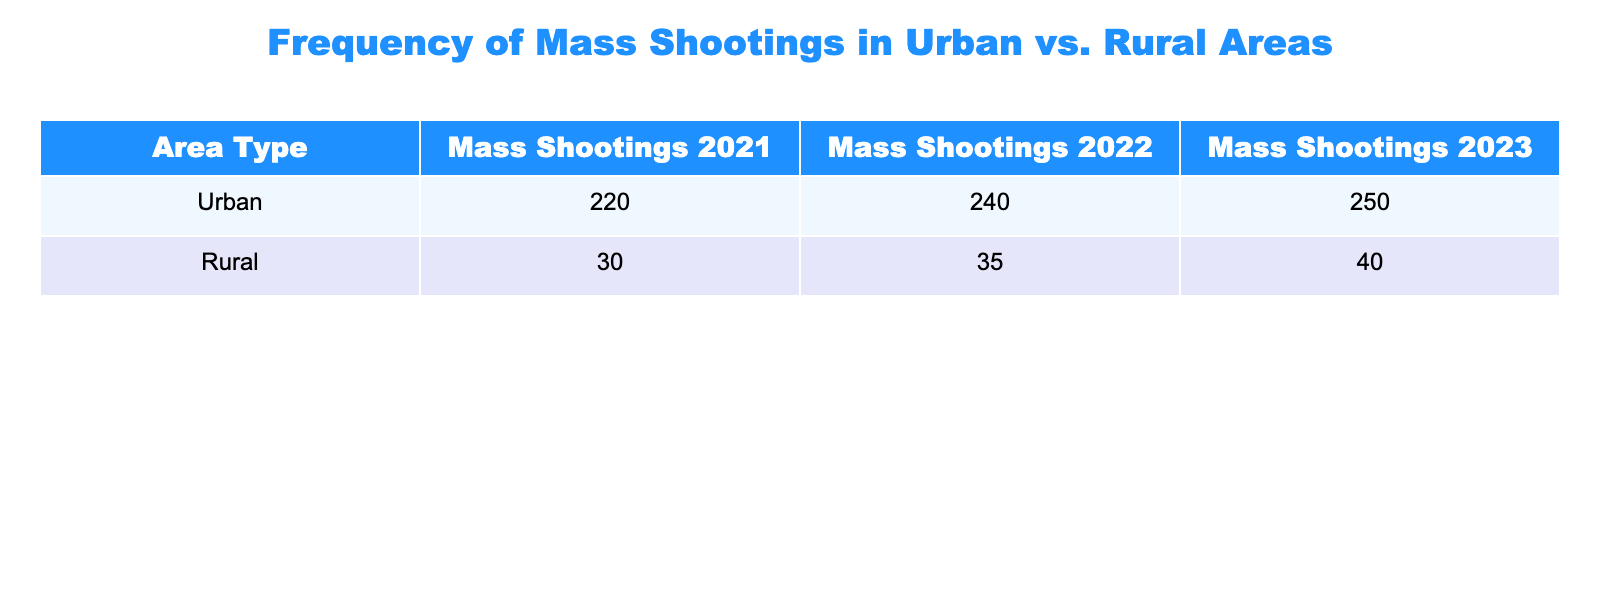What is the total number of mass shootings in rural areas from 2021 to 2023? To find the total number of mass shootings in rural areas, we need to add the mass shootings for each year. This gives us 30 (2021) + 35 (2022) + 40 (2023) = 105.
Answer: 105 How many more mass shootings occurred in urban areas than in rural areas in 2022? In 2022, there were 240 mass shootings in urban areas and 35 in rural areas. To find the difference, we subtract the rural shootings from urban shootings: 240 - 35 = 205.
Answer: 205 What is the average number of mass shootings per year in urban areas over the three years provided? To calculate the average, we add the mass shootings from each year: 220 (2021) + 240 (2022) + 250 (2023) = 710. Then, we divide by 3 (the number of years), so 710 / 3 = approximately 236.67.
Answer: 236.67 Is the number of mass shootings in urban areas greater than in rural areas for all three years? By checking each year's figures: 220 (urban) vs 30 (rural) in 2021, 240 (urban) vs 35 (rural) in 2022, and 250 (urban) vs 40 (rural) in 2023, it can be confirmed that urban shootings are greater each year.
Answer: Yes Which year saw the highest number of mass shootings in urban areas, and how many were there? Looking at the urban shooting data, 2021 had 220, 2022 had 240, and 2023 had 250. The year 2023 had the highest number, with 250 mass shootings.
Answer: 2023, 250 What was the percentage increase in mass shootings in rural areas from 2021 to 2023? To calculate the percentage increase, we first find the difference: 40 (2023) - 30 (2021) = 10. Then, we divide this difference by the original value from 2021 and multiply by 100: (10 / 30) * 100 = 33.33%.
Answer: 33.33% Did the total mass shootings in urban areas increase from 2021 to 2023? The urban shootings increased from 220 in 2021 to 250 in 2023, which indicates that there was indeed an increase.
Answer: Yes What is the combined total number of mass shootings for urban areas in the table? To find this, sum the values for all three years in urban areas: 220 (2021) + 240 (2022) + 250 (2023) = 710.
Answer: 710 